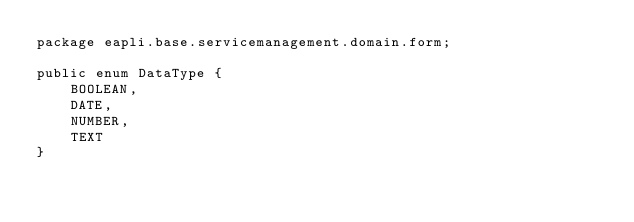<code> <loc_0><loc_0><loc_500><loc_500><_Java_>package eapli.base.servicemanagement.domain.form;

public enum DataType {
    BOOLEAN,
    DATE,
    NUMBER,
    TEXT
}

</code> 